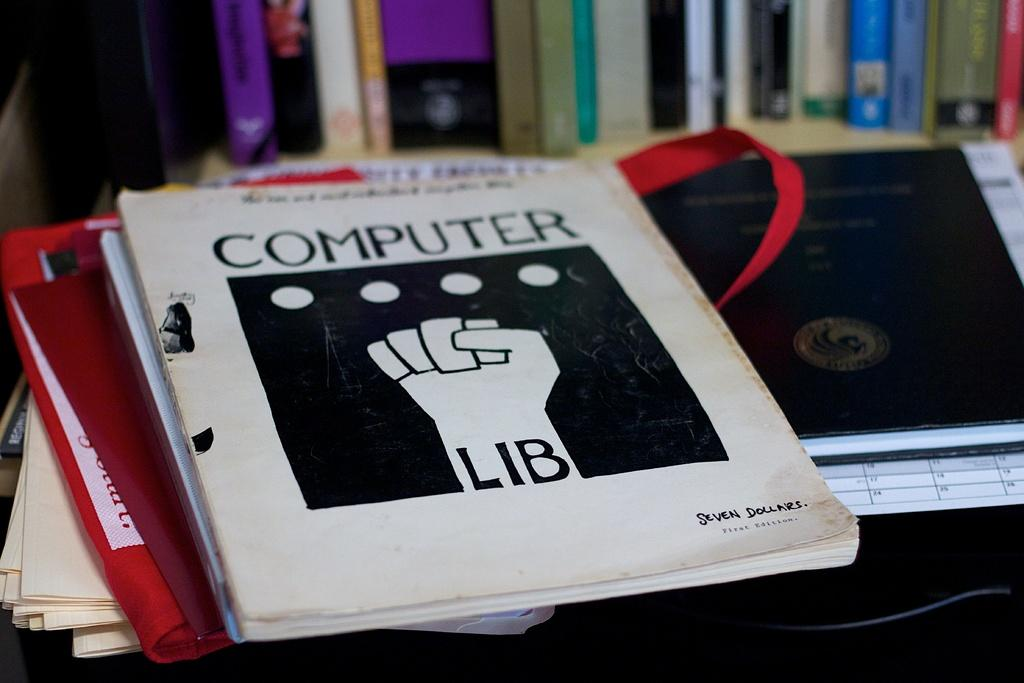<image>
Provide a brief description of the given image. A stack of books and the one on top is titled Computer Lib. 